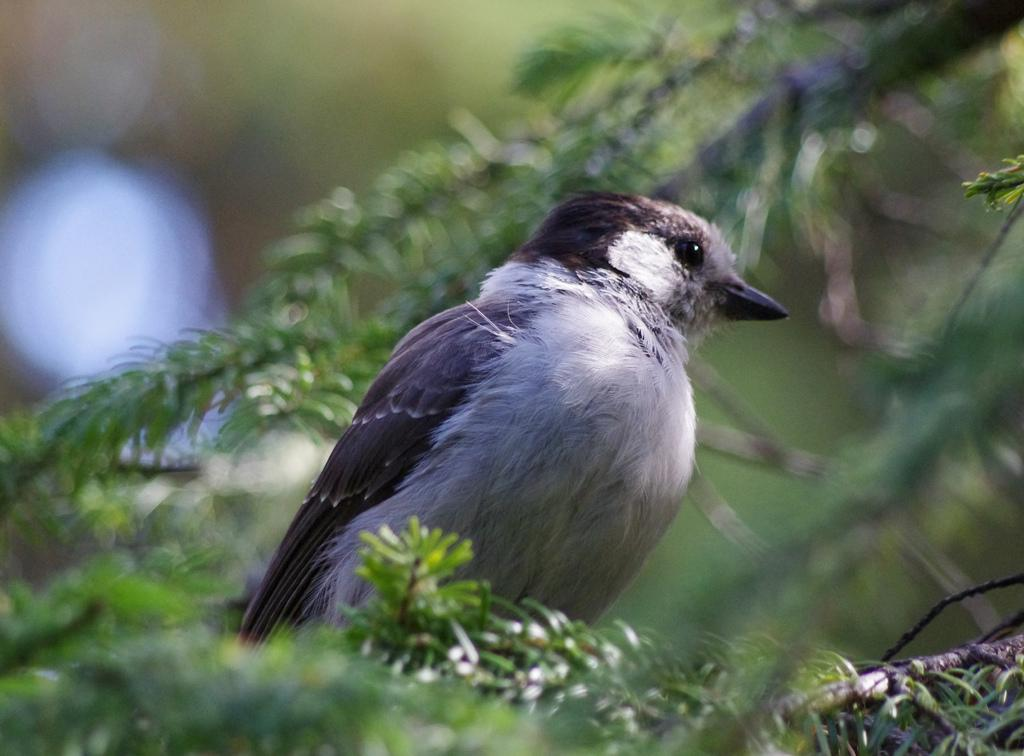What type of animal can be seen in the image? There is a bird in the image. Where is the bird located in the image? The bird is on a tree branch. Can you describe the position of the tree branch in the image? The tree branch is in the center of the image. What type of button is the bird using to fly in the image? There is no button present in the image, and birds do not use buttons to fly. 